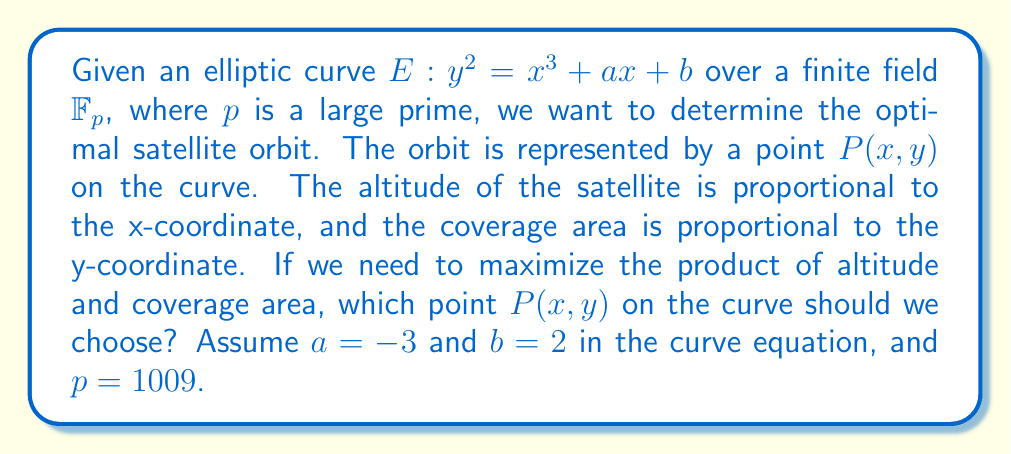What is the answer to this math problem? To solve this problem, we need to follow these steps:

1) The objective is to maximize the product $xy$, where $(x,y)$ is a point on the elliptic curve $E: y^2 = x^3 - 3x + 2$ over $\mathbb{F}_{1009}$.

2) We need to find all points on the curve and calculate the product $xy$ for each point.

3) The curve equation is: $y^2 \equiv x^3 - 3x + 2 \pmod{1009}$

4) For each $x \in \mathbb{F}_{1009}$, we calculate $z = x^3 - 3x + 2 \pmod{1009}$.

5) If $z$ is a quadratic residue modulo 1009, then we have two points $(x, \pm \sqrt{z})$ on the curve.

6) We can use the Legendre symbol and quadratic reciprocity to determine if $z$ is a quadratic residue:
   $(\frac{z}{1009}) = z^{\frac{1009-1}{2}} \pmod{1009}$

7) If the result is 1, $z$ is a quadratic residue, and we can find $y$ using the modular square root algorithm.

8) After finding all points, we calculate $xy$ for each point and find the maximum.

9) The point with the maximum $xy$ product is the optimal orbit.

[asy]
import graph;
size(200,200);
real f(real x) {return sqrt(x^3-3x+2);}
draw(graph(f,-2,2));
draw(graph(-f,-2,2));
label("$E: y^2 = x^3 - 3x + 2$", (1.5,2));
[/asy]
Answer: $P(514, 240)$ with $xy = 123360$ 